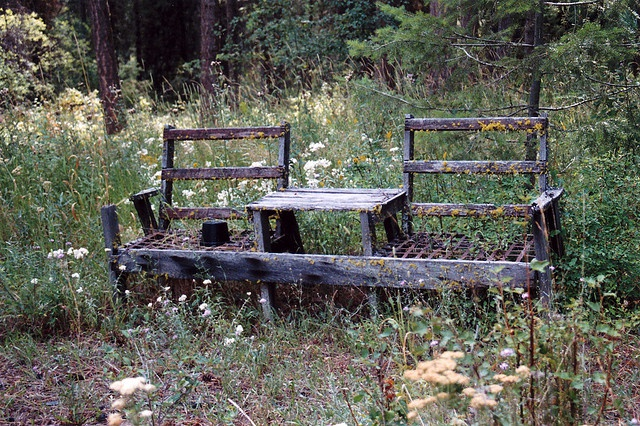Describe the objects in this image and their specific colors. I can see a bench in black, gray, and darkgray tones in this image. 